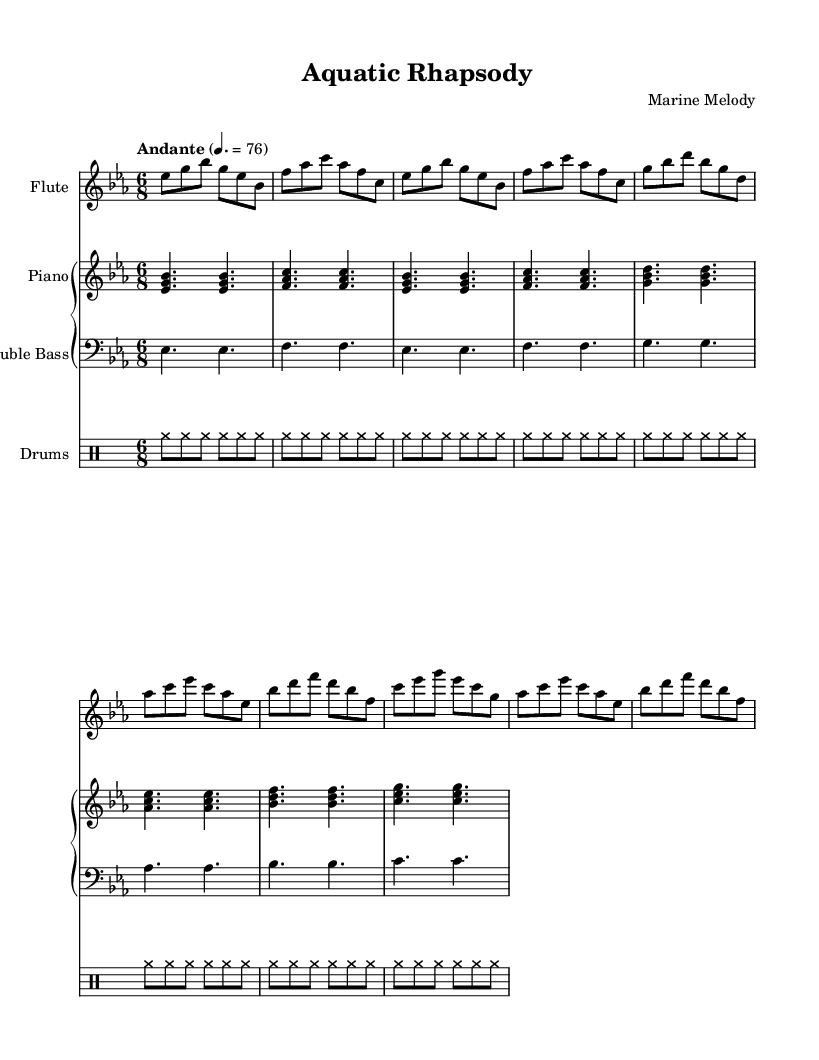what is the key signature of this music? The key signature is indicated by the presence of three flats (B flat, E flat, and A flat) on the staff. The first flat is B flat, followed by E flat and A flat, confirming the key of E flat major.
Answer: E flat major what is the time signature of this music? The time signature is shown right after the key signature. It reads "6/8," which means there are six eighth notes in each measure.
Answer: 6/8 what is the tempo marking of this music? The tempo marking is given as "Andante" with a metronome marking of 76, indicating a moderate pace. "Andante" generally conveys a walking speed.
Answer: Andante, 76 how many instruments are featured in this composition? By analyzing the score layout, we can see there are four distinct instrument parts: Flute, Piano (with Bass), and Drums. This totals four instrumental parts.
Answer: Four which instrument plays the highest pitch in this composition? The flute part is notated in a higher octave than both the piano and bass parts. The highest notes in the score belong to the flute sections which reach a higher pitch range.
Answer: Flute what is the rhythmic pattern used in the drum part? The drum part consists of a repeating pattern indicated by the use of the cymbal notes. It is consistent across the measures, emphasizing a steady rhythm typically seen in jazz compositions, reflecting the natural movements of fish.
Answer: Cymbal rhythm what do the dynamics indicate about the flute's part? The flute part does not specify any dynamics like "p" (piano) or "f" (forte), indicating it is to be played at a moderate, consistent volume meant to blend with the overall ensemble, typical of jazz where subtlety is key.
Answer: Moderate volume 